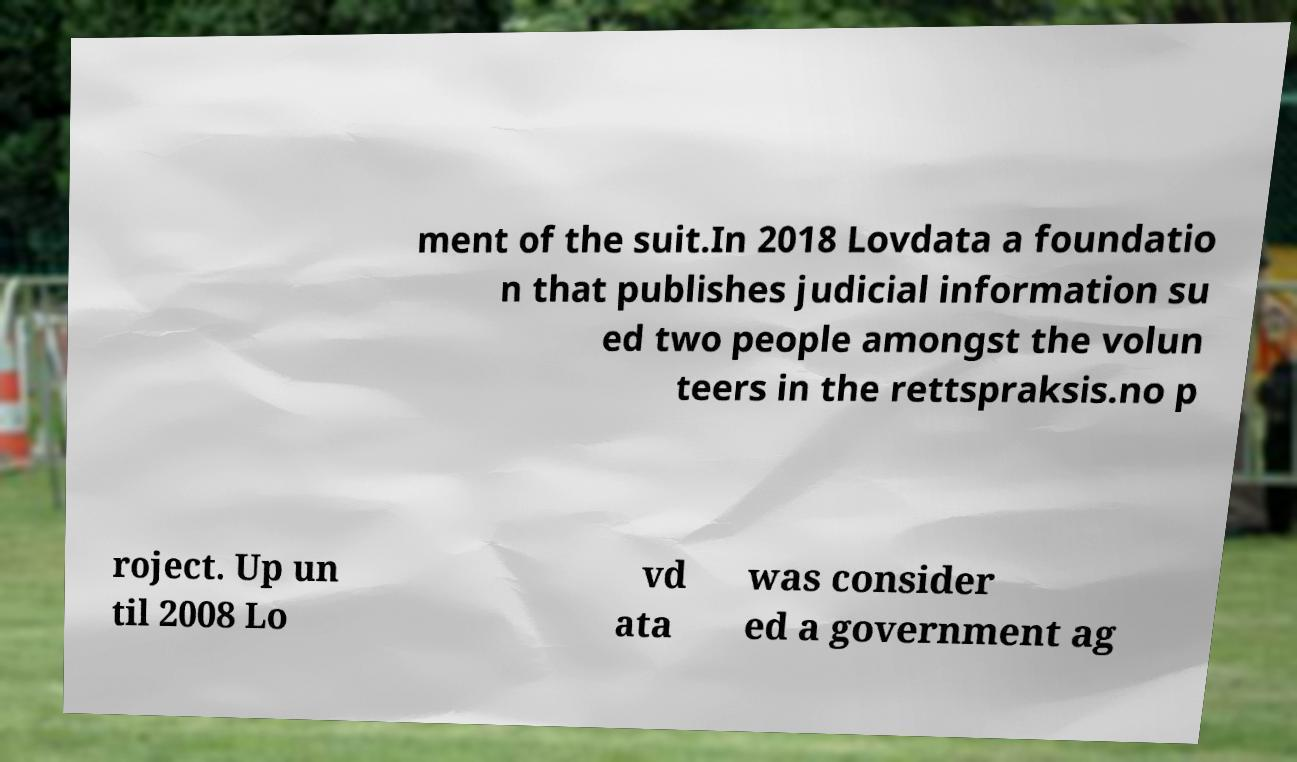Can you read and provide the text displayed in the image?This photo seems to have some interesting text. Can you extract and type it out for me? ment of the suit.In 2018 Lovdata a foundatio n that publishes judicial information su ed two people amongst the volun teers in the rettspraksis.no p roject. Up un til 2008 Lo vd ata was consider ed a government ag 